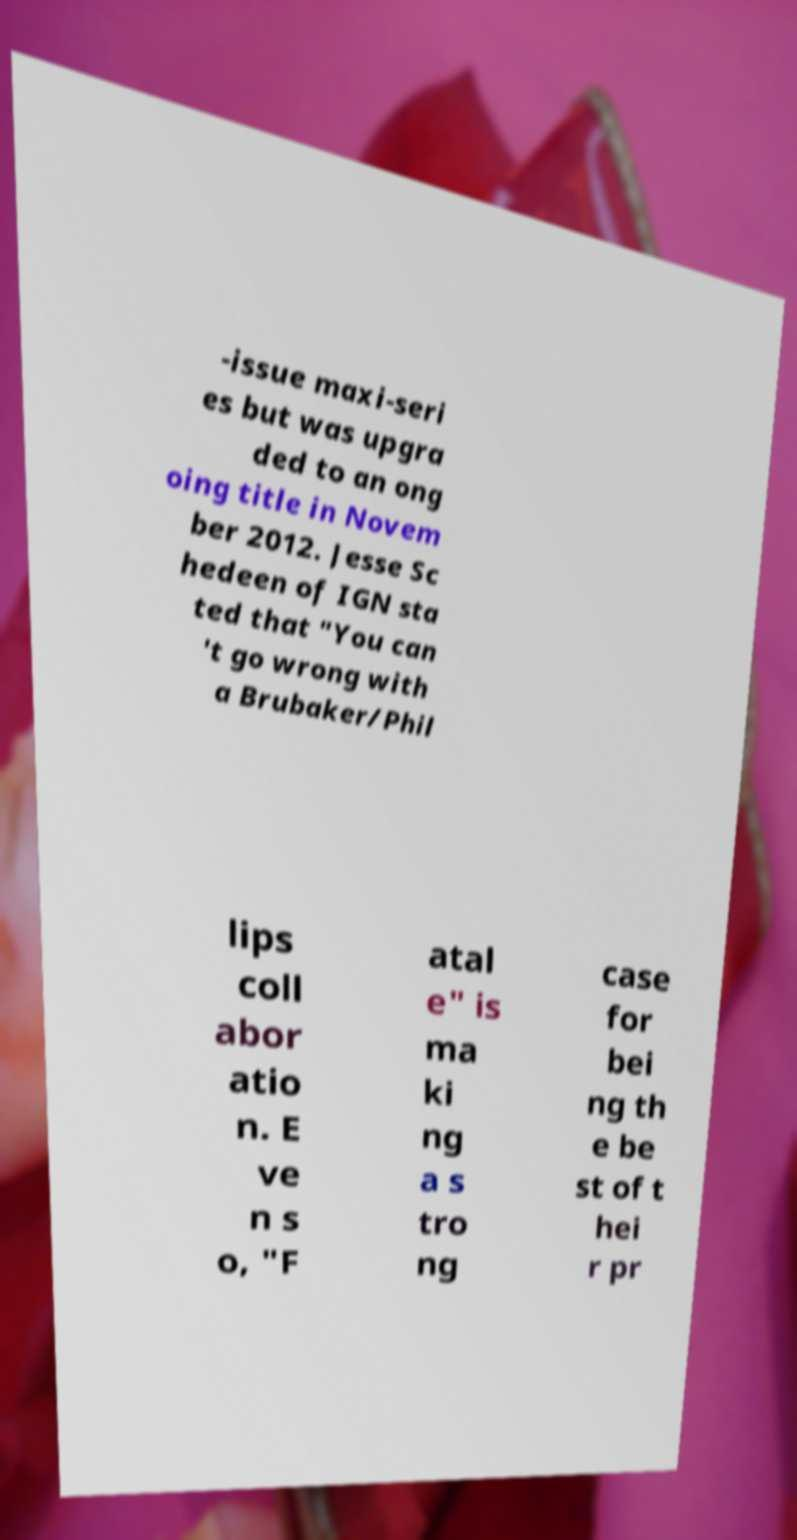Can you read and provide the text displayed in the image?This photo seems to have some interesting text. Can you extract and type it out for me? -issue maxi-seri es but was upgra ded to an ong oing title in Novem ber 2012. Jesse Sc hedeen of IGN sta ted that "You can 't go wrong with a Brubaker/Phil lips coll abor atio n. E ve n s o, "F atal e" is ma ki ng a s tro ng case for bei ng th e be st of t hei r pr 